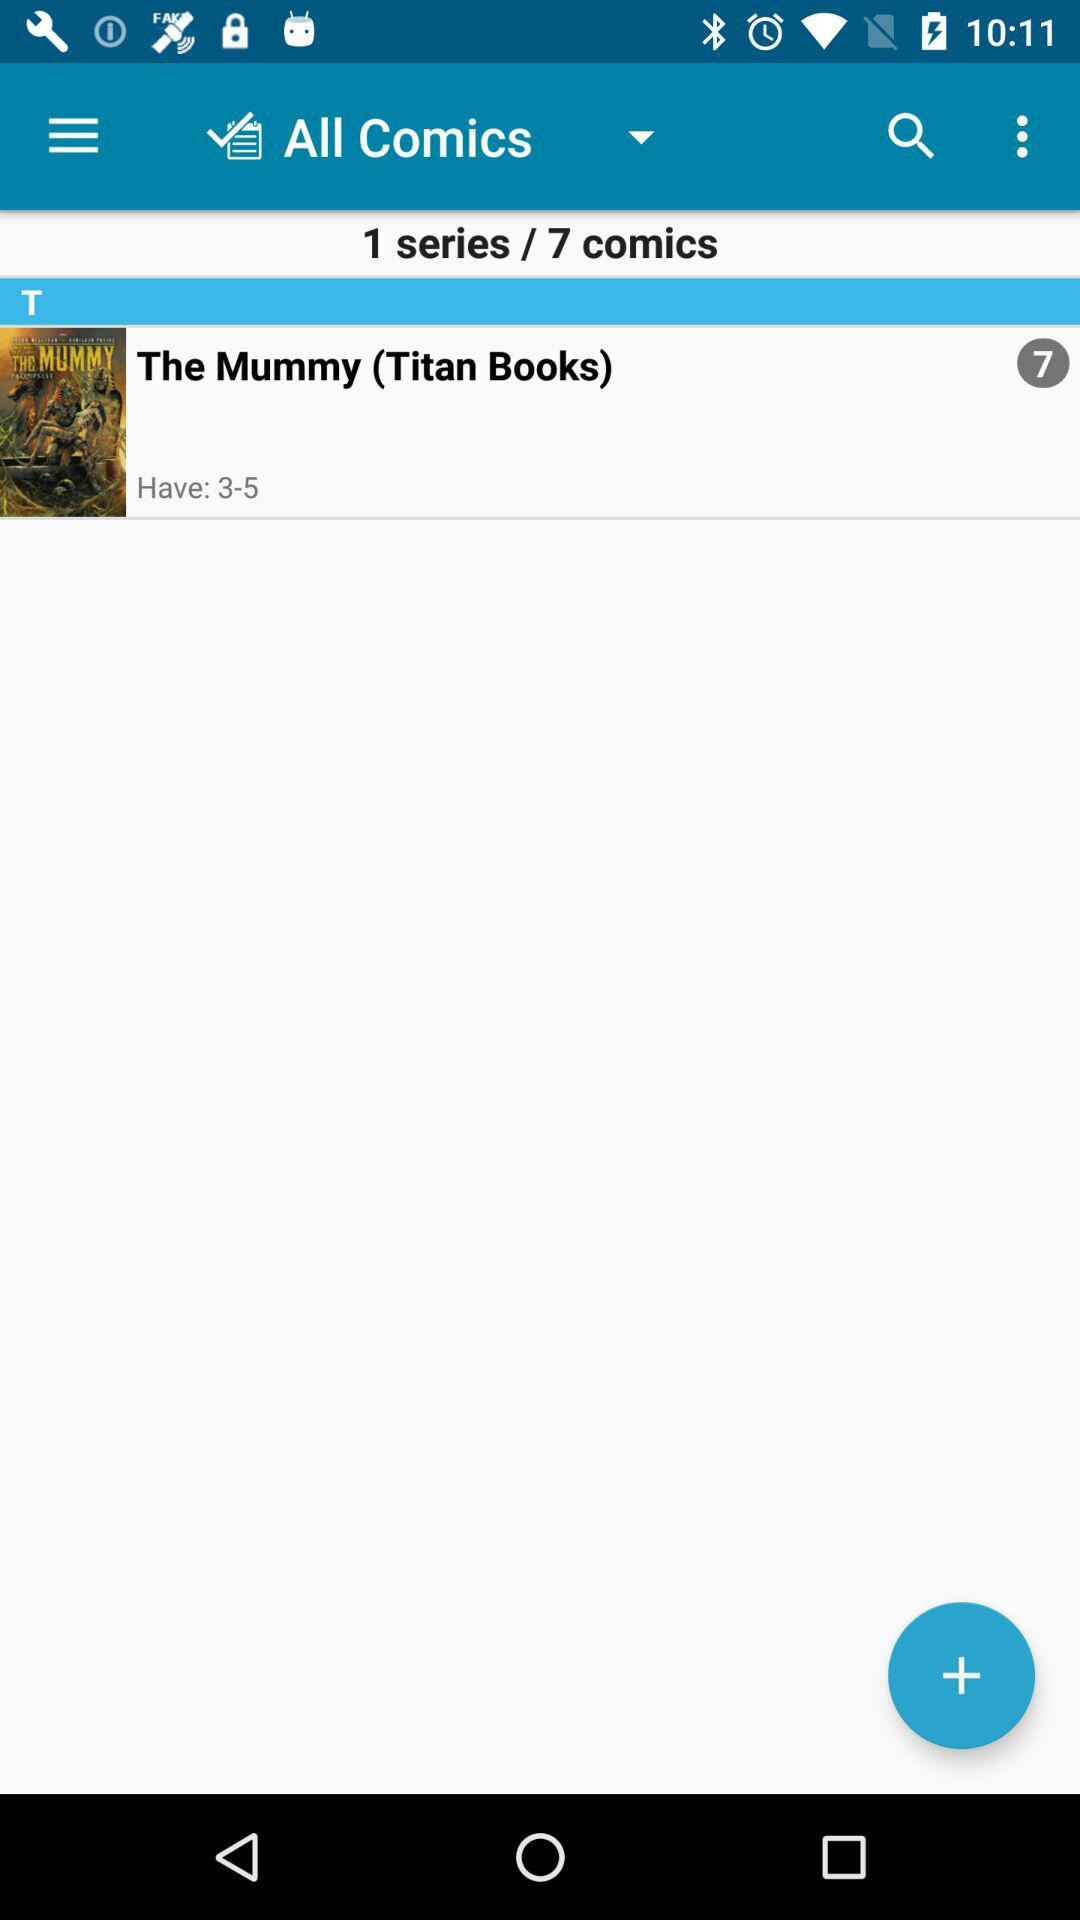How many comics are there? There are 7 comics. 